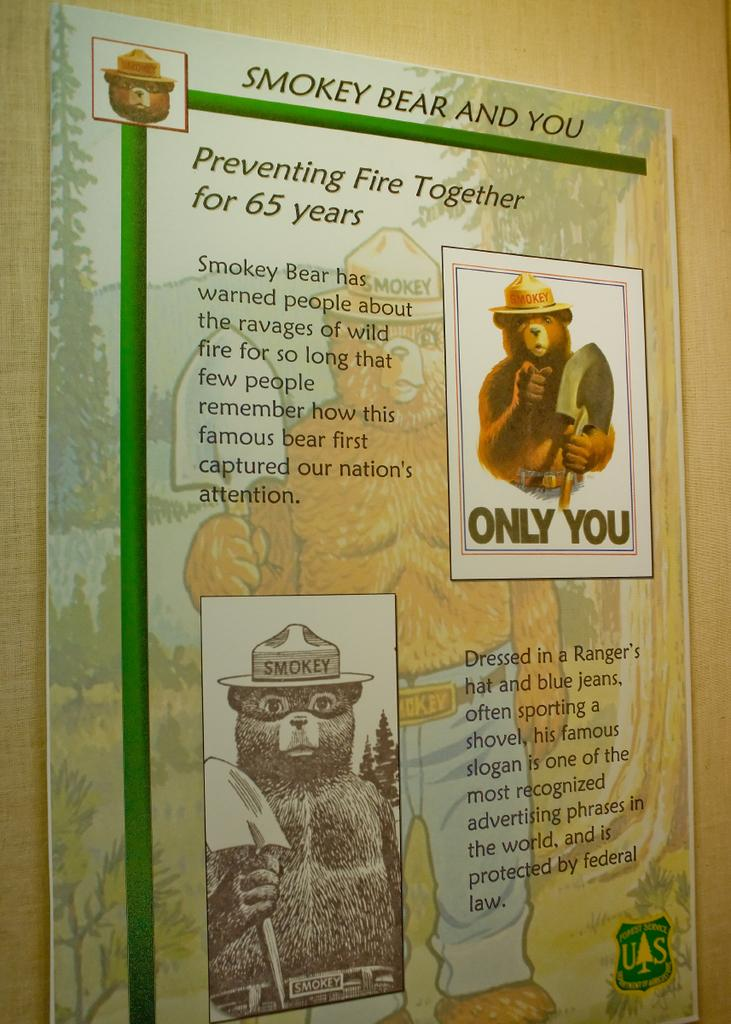<image>
Create a compact narrative representing the image presented. A smokey the bear posting detailing how it has been preventing forest fires for 65 years. 